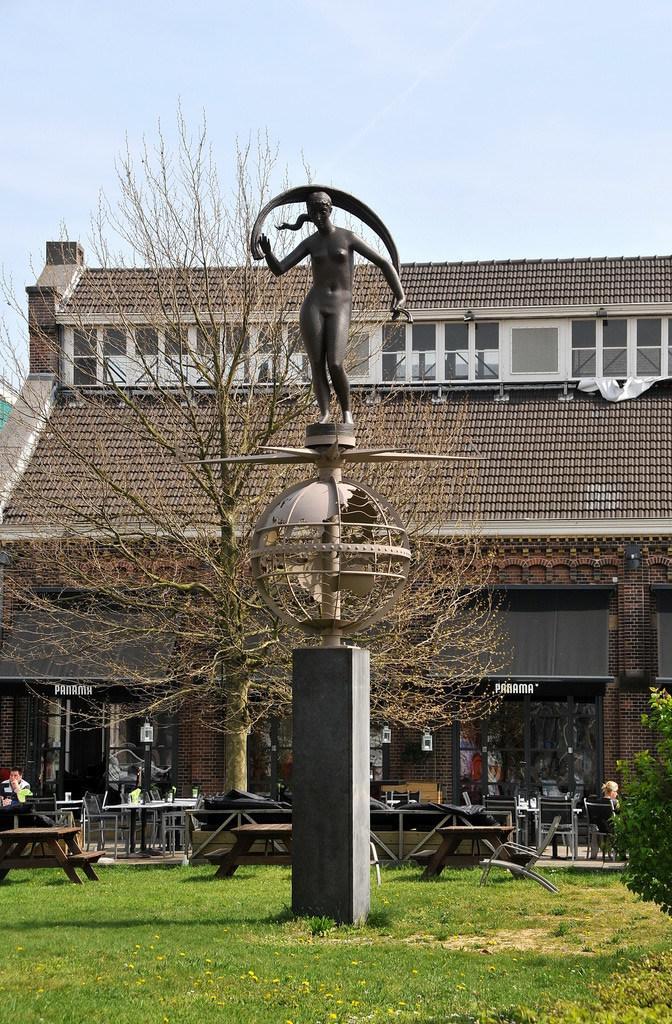Describe this image in one or two sentences. In the picture there is a pillar and top of the pillar there is a sculpture in the background there is a tree , some tables and back side of it there is a building and sky. 